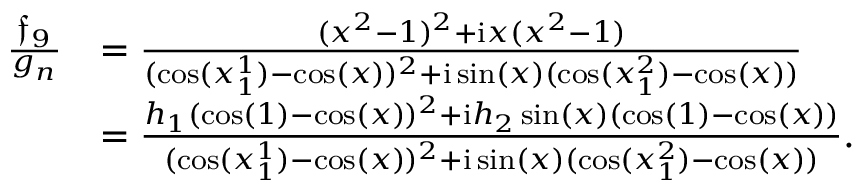<formula> <loc_0><loc_0><loc_500><loc_500>\begin{array} { r l } { \frac { \mathfrak { f } _ { 9 } } { g _ { n } } } & { = \frac { ( x ^ { 2 } - 1 ) ^ { 2 } + i x ( x ^ { 2 } - 1 ) } { ( \cos ( x _ { 1 } ^ { 1 } ) - \cos ( x ) ) ^ { 2 } + i \sin ( x ) ( \cos ( x _ { 1 } ^ { 2 } ) - \cos ( x ) ) } } \\ & { = \frac { h _ { 1 } ( \cos ( 1 ) - \cos ( x ) ) ^ { 2 } + i h _ { 2 } \sin ( x ) ( \cos ( 1 ) - \cos ( x ) ) } { ( \cos ( x _ { 1 } ^ { 1 } ) - \cos ( x ) ) ^ { 2 } + i \sin ( x ) ( \cos ( x _ { 1 } ^ { 2 } ) - \cos ( x ) ) } . } \end{array}</formula> 